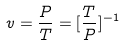<formula> <loc_0><loc_0><loc_500><loc_500>v = \frac { P } { T } = [ \frac { T } { P } ] ^ { - 1 }</formula> 